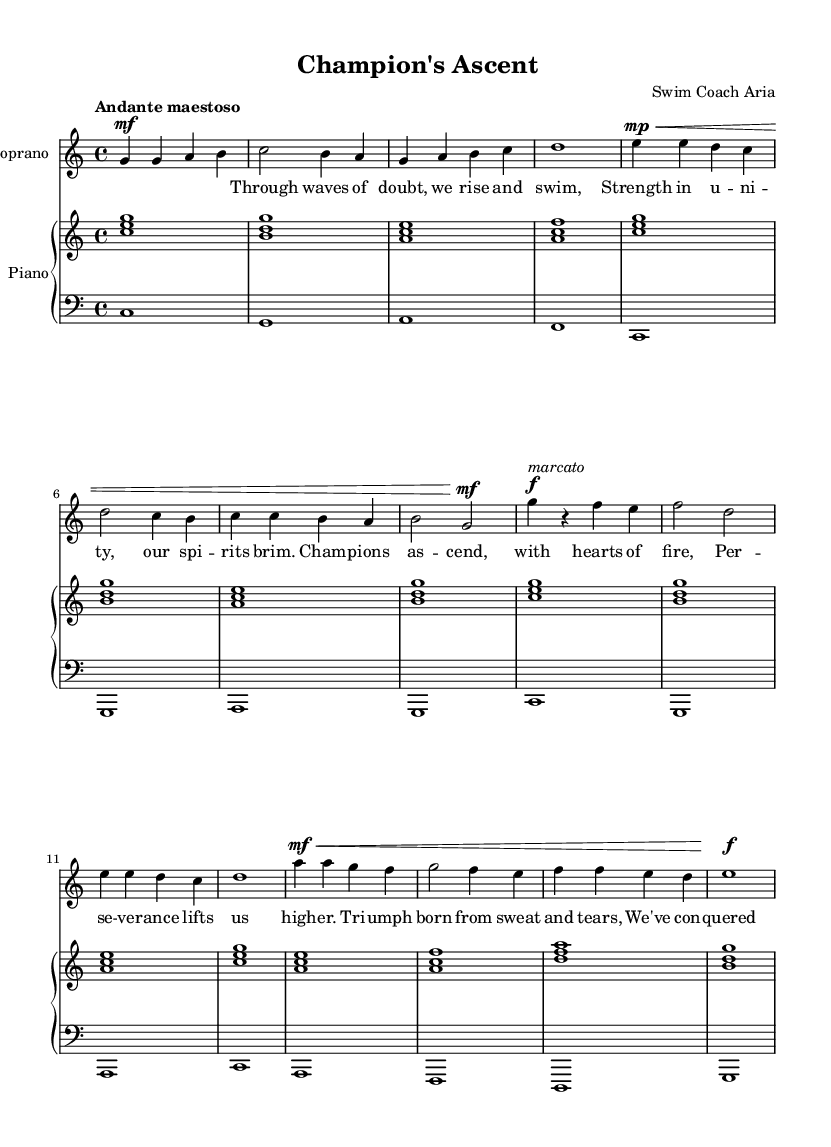What is the key signature of this music? The key signature is indicated at the beginning of the sheet music, and it shows no sharps or flats, which corresponds to C major.
Answer: C major What is the time signature of the piece? The time signature, shown at the beginning of the sheet music, is 4/4, meaning there are four beats in each measure and a quarter note receives one beat.
Answer: 4/4 What is the tempo marking for this aria? The tempo marking, indicated at the beginning of the score, states "Andante maestoso," which describes a slow and stately pace for the music.
Answer: Andante maestoso How many measures does the verse section contain? The verse section consists of four measures, as counted from the beginning of the verse lyrics to the end of that segment.
Answer: Four measures Which dynamic marking is present in the chorus? The chorus section contains a dynamic marking of "forte" (f), indicating a loud and powerful vocal volume during this section.
Answer: Forte What textual theme is expressed in the bridge of the aria? The bridge reflects a theme of overcoming challenges and resilience, as shown in the lyrics that speak about triumph coming from effort and conquering fears.
Answer: Resilience Identify the type of musical work this piece represents. This piece is an aria from an opera, characterized by its focus on expressiveness and individual vocal performance often within a dramatic narrative.
Answer: Opera aria 